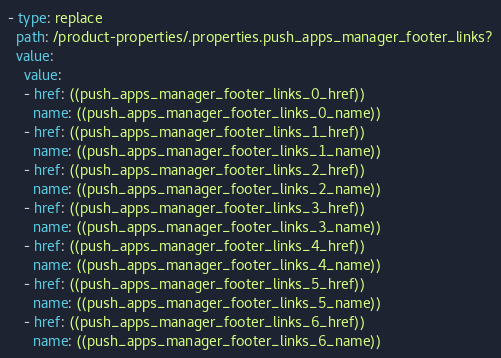<code> <loc_0><loc_0><loc_500><loc_500><_YAML_>- type: replace
  path: /product-properties/.properties.push_apps_manager_footer_links?
  value:
    value:
    - href: ((push_apps_manager_footer_links_0_href))
      name: ((push_apps_manager_footer_links_0_name))
    - href: ((push_apps_manager_footer_links_1_href))
      name: ((push_apps_manager_footer_links_1_name))
    - href: ((push_apps_manager_footer_links_2_href))
      name: ((push_apps_manager_footer_links_2_name))
    - href: ((push_apps_manager_footer_links_3_href))
      name: ((push_apps_manager_footer_links_3_name))
    - href: ((push_apps_manager_footer_links_4_href))
      name: ((push_apps_manager_footer_links_4_name))
    - href: ((push_apps_manager_footer_links_5_href))
      name: ((push_apps_manager_footer_links_5_name))
    - href: ((push_apps_manager_footer_links_6_href))
      name: ((push_apps_manager_footer_links_6_name))
</code> 